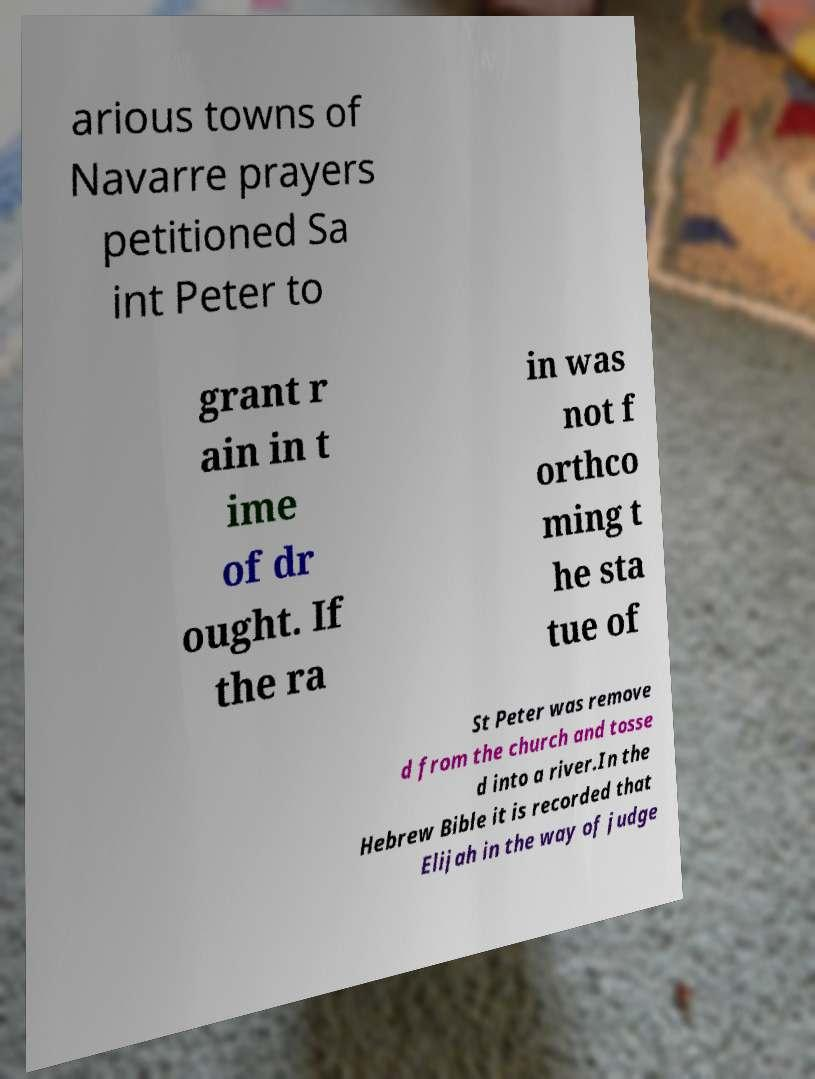Could you extract and type out the text from this image? arious towns of Navarre prayers petitioned Sa int Peter to grant r ain in t ime of dr ought. If the ra in was not f orthco ming t he sta tue of St Peter was remove d from the church and tosse d into a river.In the Hebrew Bible it is recorded that Elijah in the way of judge 